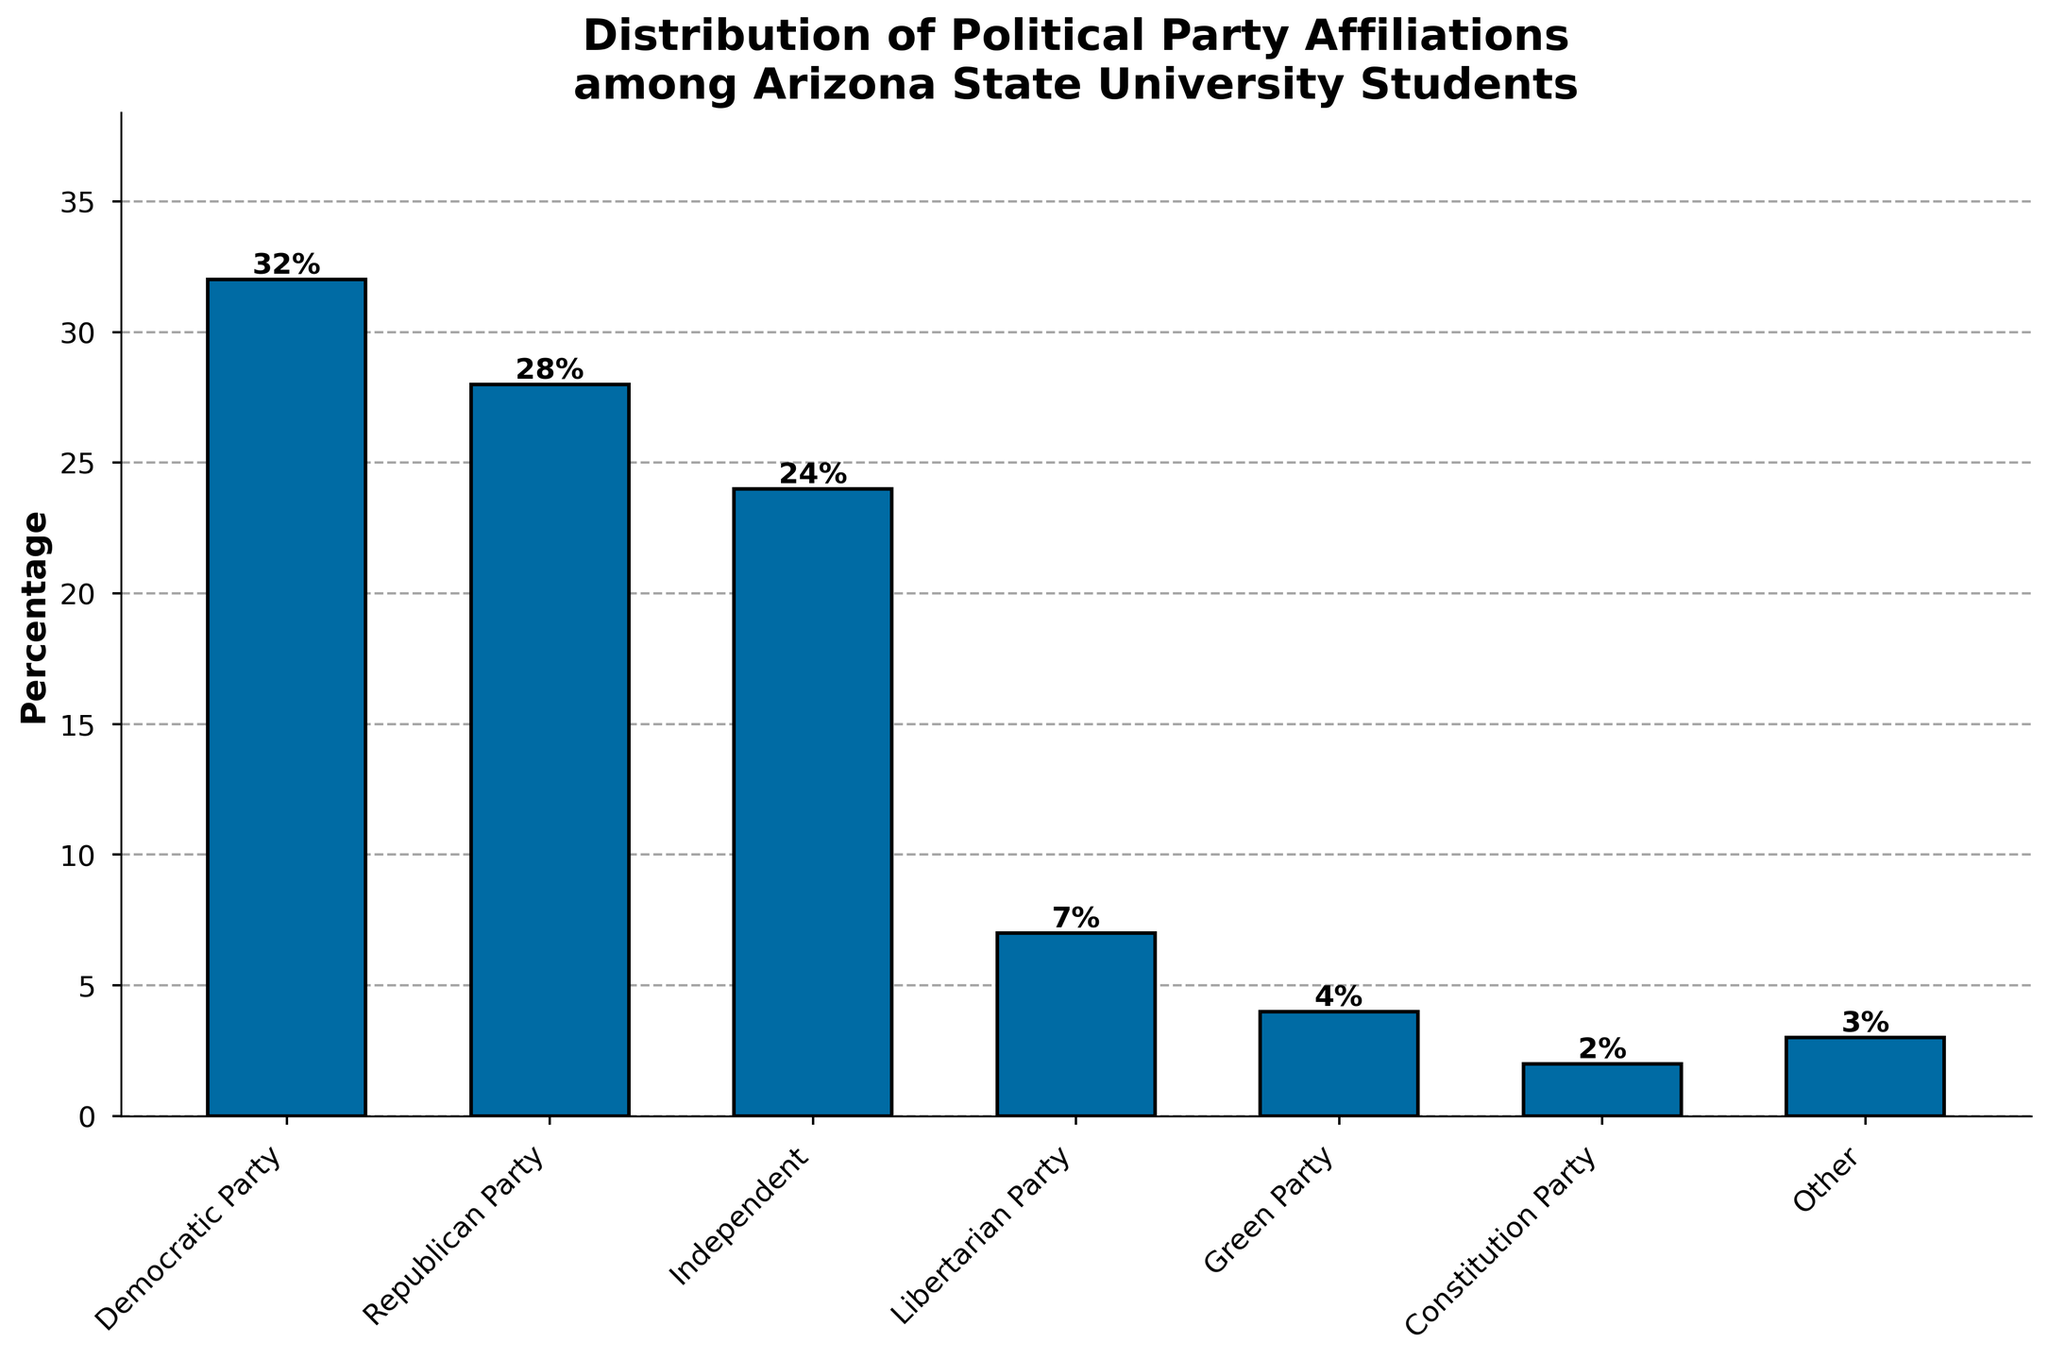Which political party has the highest percentage of affiliations among Arizona State University students? The bar chart shows that the Democratic Party has the highest percentage.
Answer: Democratic Party What is the combined percentage of students affiliated with the Democratic Party and the Republican Party? According to the chart, the Democratic Party has 32% and the Republican Party has 28%. Adding these together, 32 + 28 = 60%.
Answer: 60% Which party has the lowest percentage of affiliations among the students? By observing the heights of the bars, the Constitution Party has the lowest percentage at 2%.
Answer: Constitution Party How many percentage points higher is the Democratic Party affiliation compared to the Green Party? The Democratic Party has 32% and the Green Party has 4%. The difference is 32 - 4 = 28 percentage points.
Answer: 28 percentage points Are there more students affiliated with the Independent or the Libertarian Party? By comparing the heights of the bars, the Independent Party has 24%, while the Libertarian Party has 7%. Therefore, the Independent Party has more affiliations.
Answer: Independent Party What is the percentage difference between students affiliated with the Republican Party and those with the Libertarian Party? The Republican Party has 28% and the Libertarian Party has 7%. The percentage difference is 28 - 7 = 21%.
Answer: 21% What is the average percentage of the students affiliated with the Green Party, Constitution Party, and Other? The percentages are 4% for the Green Party, 2% for the Constitution Party, and 3% for Other. The average is (4 + 2 + 3) / 3 = 3%.
Answer: 3% Which affiliation group has the closest percentage to the Independent Party? The chart shows the Independent Party has 24%. The closest percentage is the Republican Party with 28%, which is 4 percentage points away.
Answer: Republican Party How many more percentage points do the Democratic and Republican Parties together have compared to all other affiliations combined? Democratic (32%) + Republican (28%) = 60%. The combined other affiliations are Independent (24%), Libertarian (7%), Green (4%), Constitution (2%), and Other (3%), totaling 40%. The difference is 60 - 40 = 20 percentage points.
Answer: 20 percentage points 